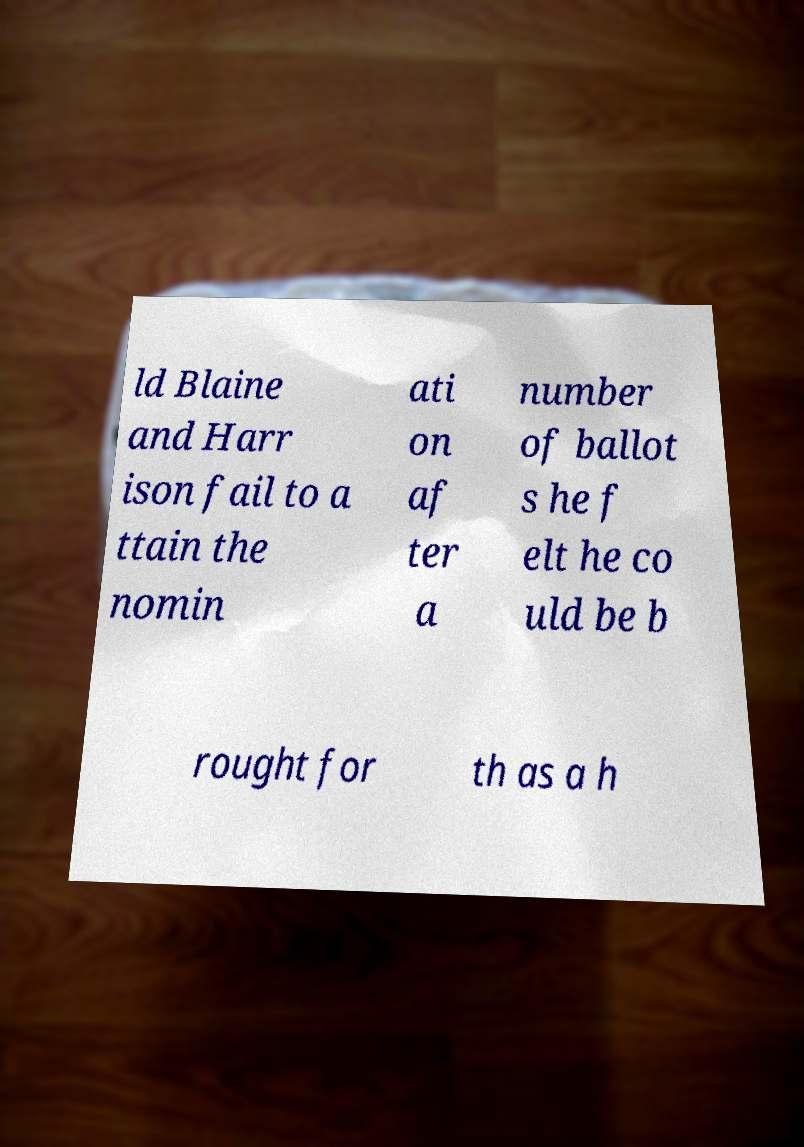For documentation purposes, I need the text within this image transcribed. Could you provide that? ld Blaine and Harr ison fail to a ttain the nomin ati on af ter a number of ballot s he f elt he co uld be b rought for th as a h 